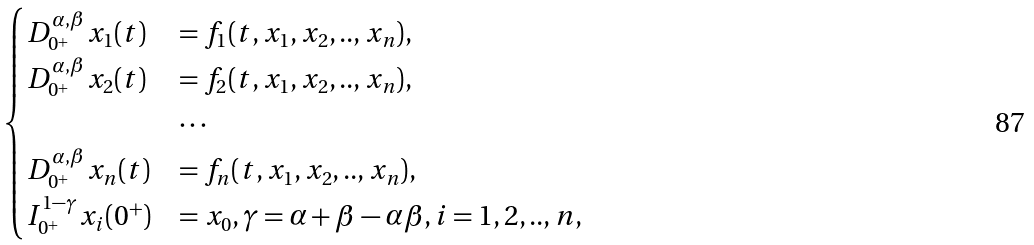<formula> <loc_0><loc_0><loc_500><loc_500>\begin{cases} D _ { 0 ^ { + } } ^ { \alpha , \beta } x _ { 1 } ( t ) & = f _ { 1 } ( t , x _ { 1 } , x _ { 2 } , . . , x _ { n } ) , \\ D _ { 0 ^ { + } } ^ { \alpha , \beta } x _ { 2 } ( t ) & = f _ { 2 } ( t , x _ { 1 } , x _ { 2 } , . . , x _ { n } ) , \\ & \cdots \\ D _ { 0 ^ { + } } ^ { \alpha , \beta } x _ { n } ( t ) & = f _ { n } ( t , x _ { 1 } , x _ { 2 } , . . , x _ { n } ) , \\ I _ { 0 ^ { + } } ^ { 1 - \gamma } x _ { i } ( 0 ^ { + } ) & = x _ { 0 } , \gamma = \alpha + \beta - \alpha \beta , i = 1 , 2 , . . , n , \end{cases}</formula> 